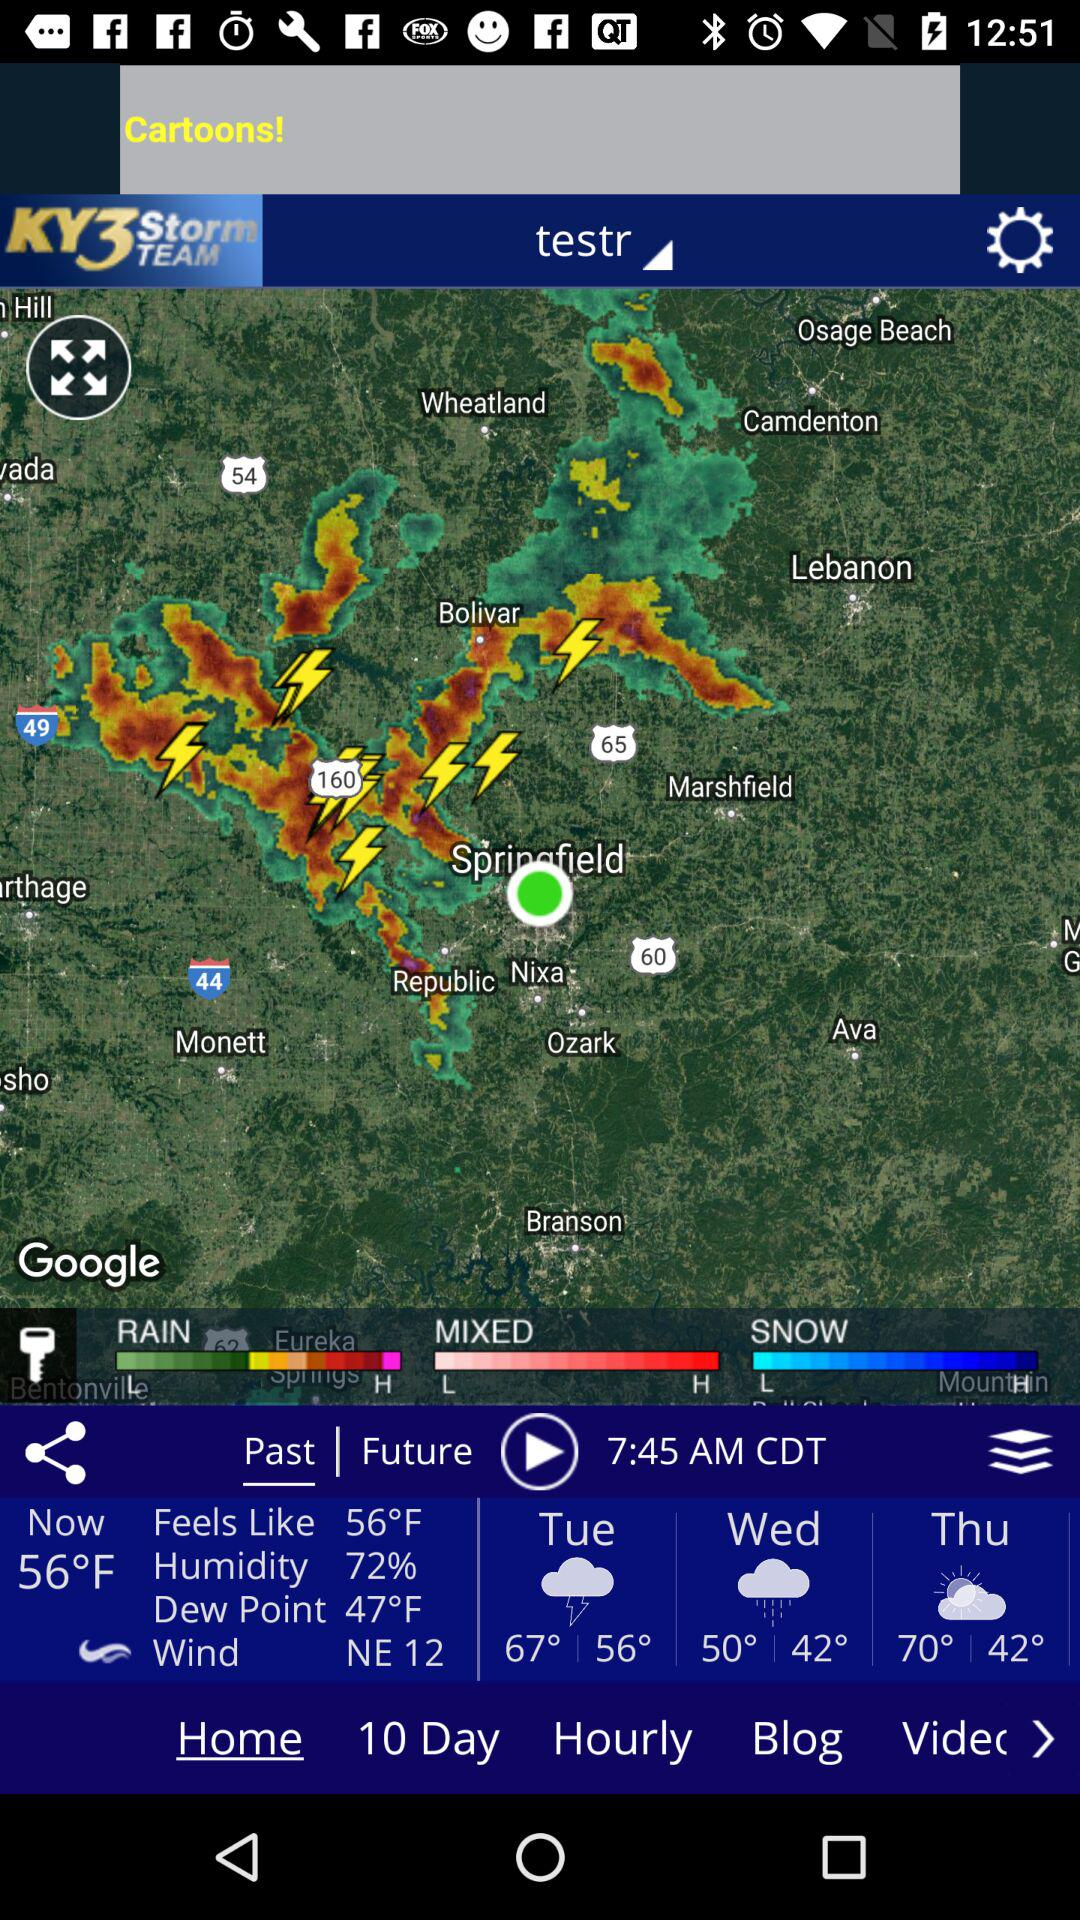How many degrees fahrenheit does it feel like?
Answer the question using a single word or phrase. 56°F 